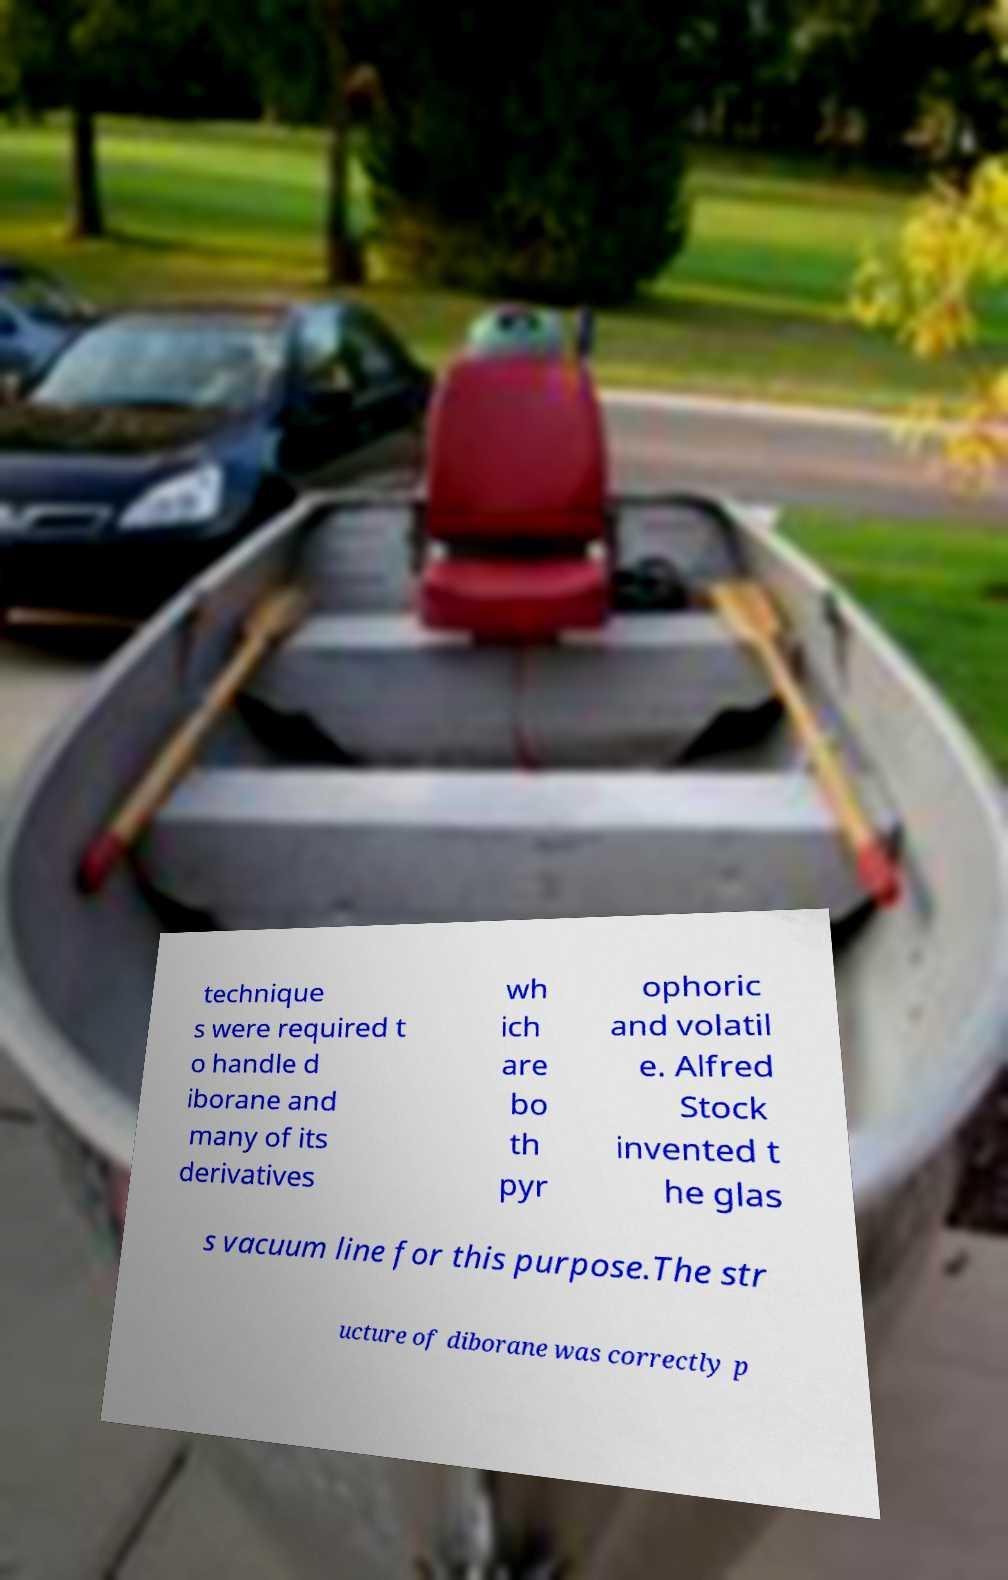Can you accurately transcribe the text from the provided image for me? technique s were required t o handle d iborane and many of its derivatives wh ich are bo th pyr ophoric and volatil e. Alfred Stock invented t he glas s vacuum line for this purpose.The str ucture of diborane was correctly p 